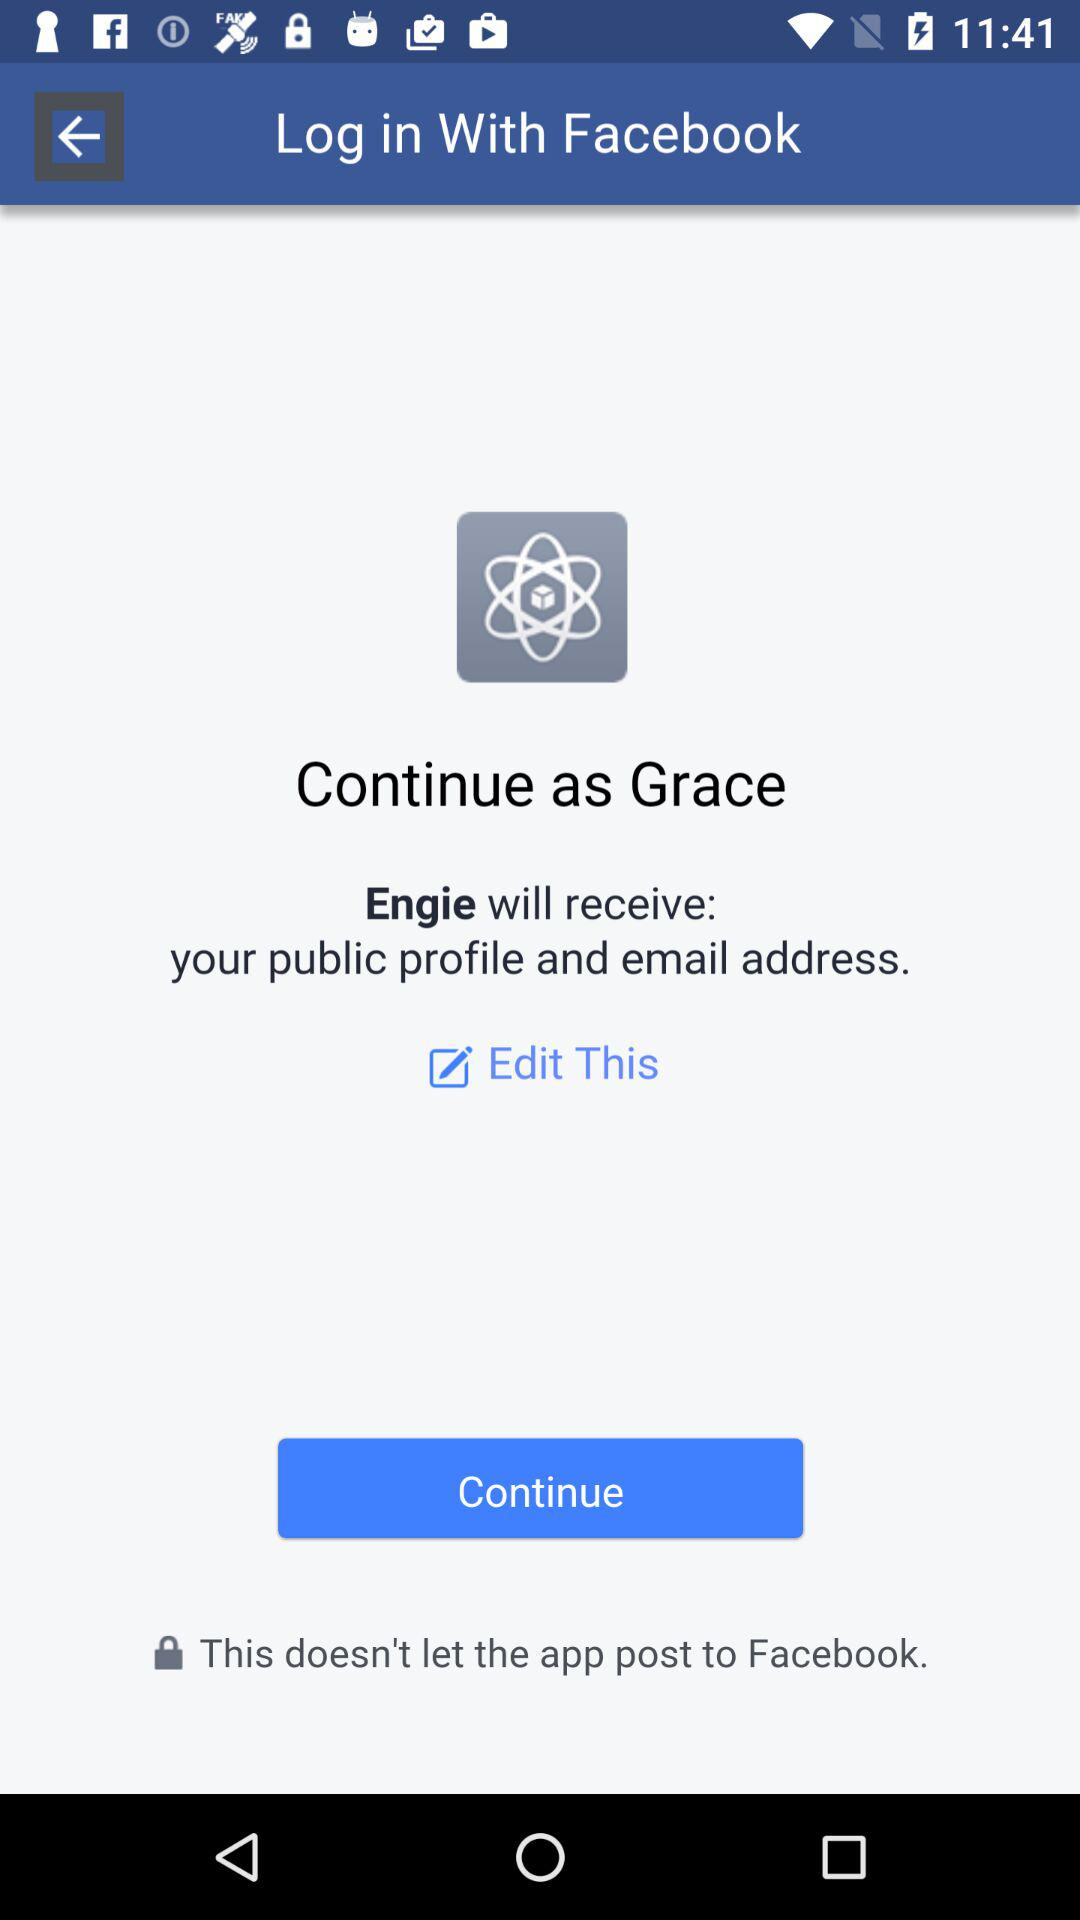What application is asking for permission? The application asking for permission is "Engie". 